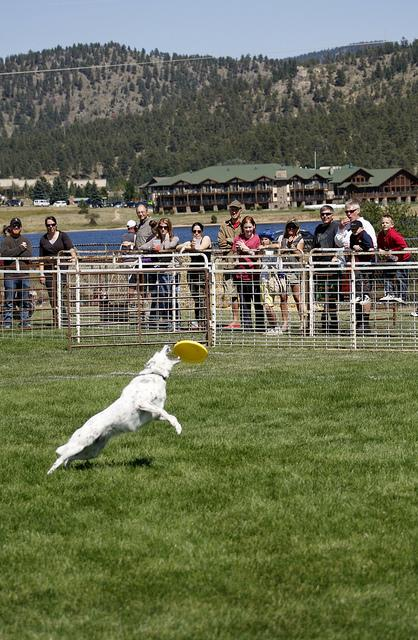Approximately how many people are watching the event? Please explain your reasoning. dozen. There are a dozen. 